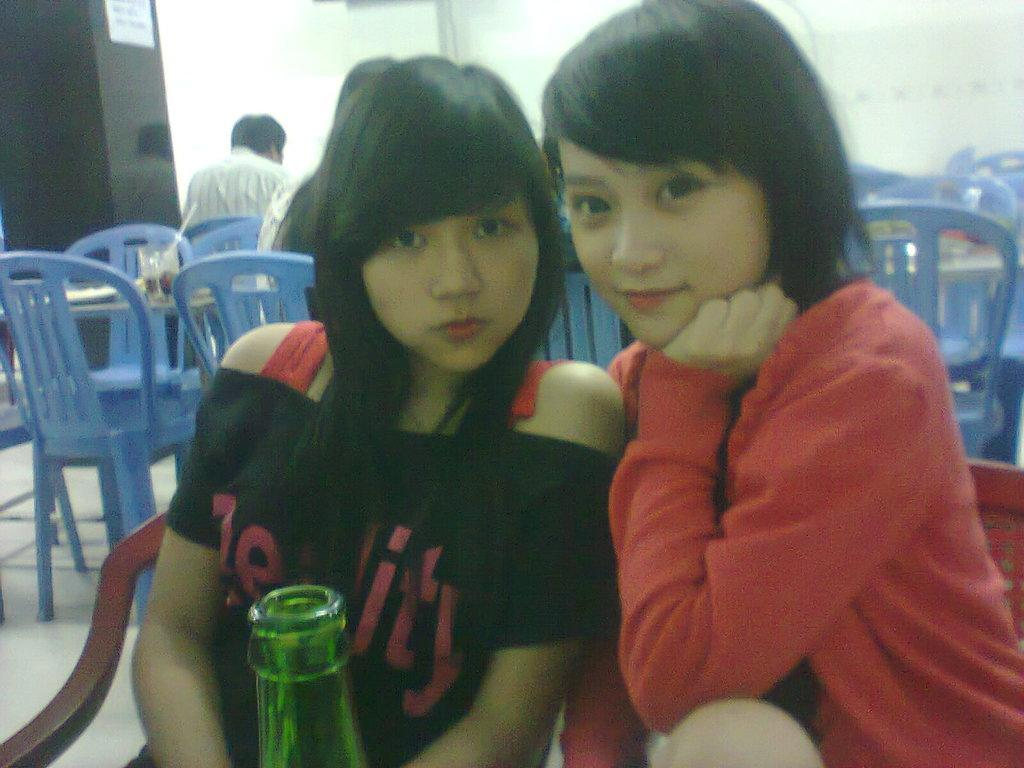How many women are in the image? There are two women in the image. What are the women doing in the image? The women are seated on chairs. What objects are on the table in the image? There is a bottle and glasses on the table. Can you describe the position of the people in the image? There are people seated on their backs. What is the opinion of the cats in the image? There are no cats present in the image, so it is not possible to determine their opinion. 